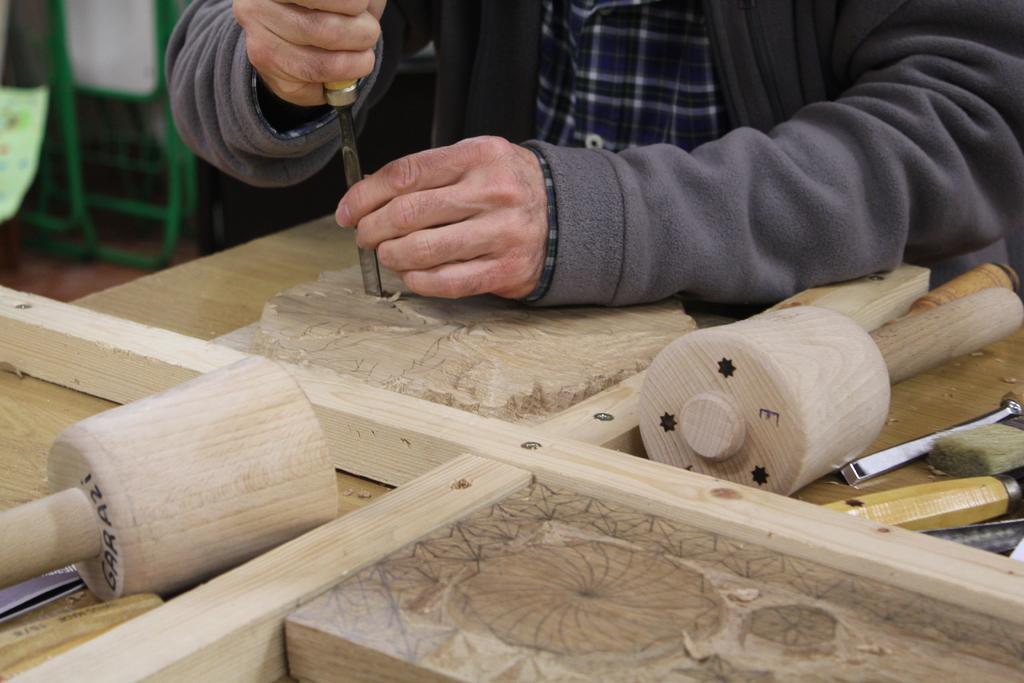Please provide a concise description of this image. In this image, we can see a person is chiseling a wood using a tool. Here we can see some wooden pieces, wooden board, some brush, tools. Left top corner, we can see few objects and floor. 